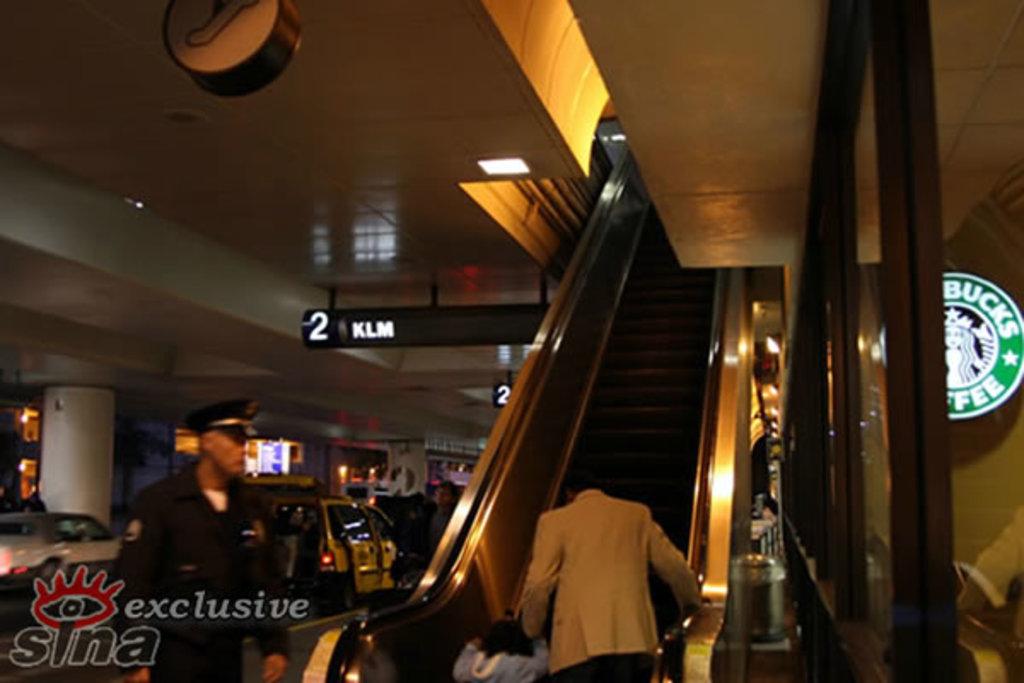What coffee shop is on the right?
Keep it short and to the point. Starbucks. 